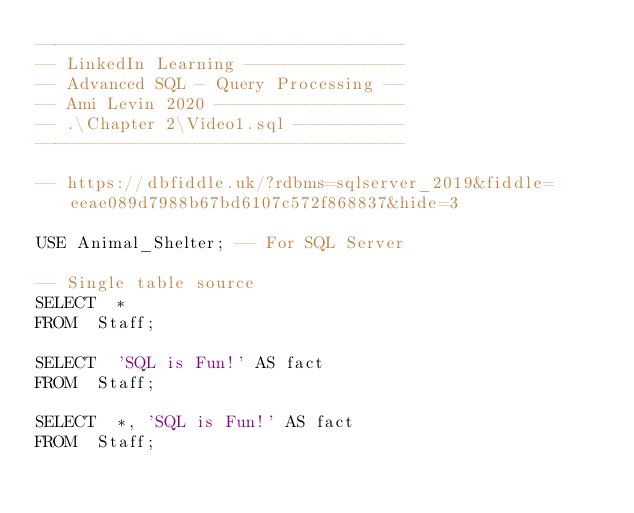Convert code to text. <code><loc_0><loc_0><loc_500><loc_500><_SQL_>-------------------------------------
-- LinkedIn Learning ----------------
-- Advanced SQL - Query Processing --
-- Ami Levin 2020 -------------------
-- .\Chapter 2\Video1.sql -----------
-------------------------------------

-- https://dbfiddle.uk/?rdbms=sqlserver_2019&fiddle=eeae089d7988b67bd6107c572f868837&hide=3

USE Animal_Shelter; -- For SQL Server

-- Single table source
SELECT	*
FROM	Staff;

SELECT	'SQL is Fun!' AS fact
FROM	Staff;

SELECT	*, 'SQL is Fun!' AS fact
FROM	Staff;
</code> 